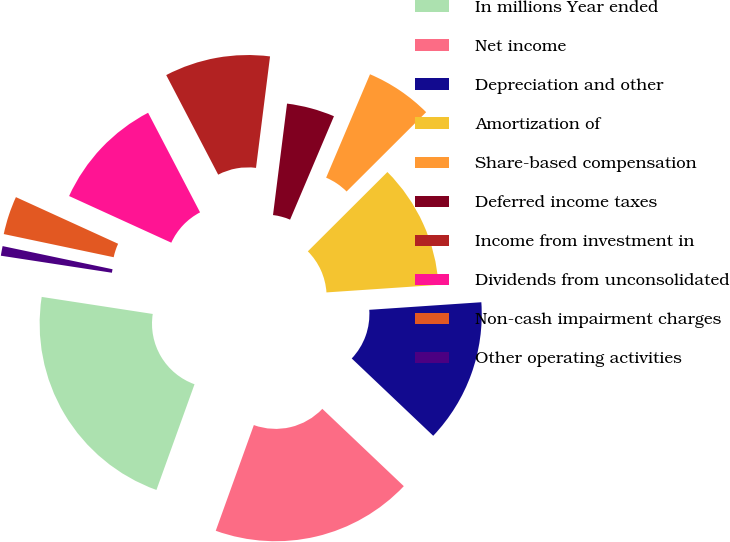<chart> <loc_0><loc_0><loc_500><loc_500><pie_chart><fcel>In millions Year ended<fcel>Net income<fcel>Depreciation and other<fcel>Amortization of<fcel>Share-based compensation<fcel>Deferred income taxes<fcel>Income from investment in<fcel>Dividends from unconsolidated<fcel>Non-cash impairment charges<fcel>Other operating activities<nl><fcel>21.92%<fcel>18.42%<fcel>13.16%<fcel>11.4%<fcel>6.14%<fcel>4.39%<fcel>9.65%<fcel>10.53%<fcel>3.51%<fcel>0.88%<nl></chart> 